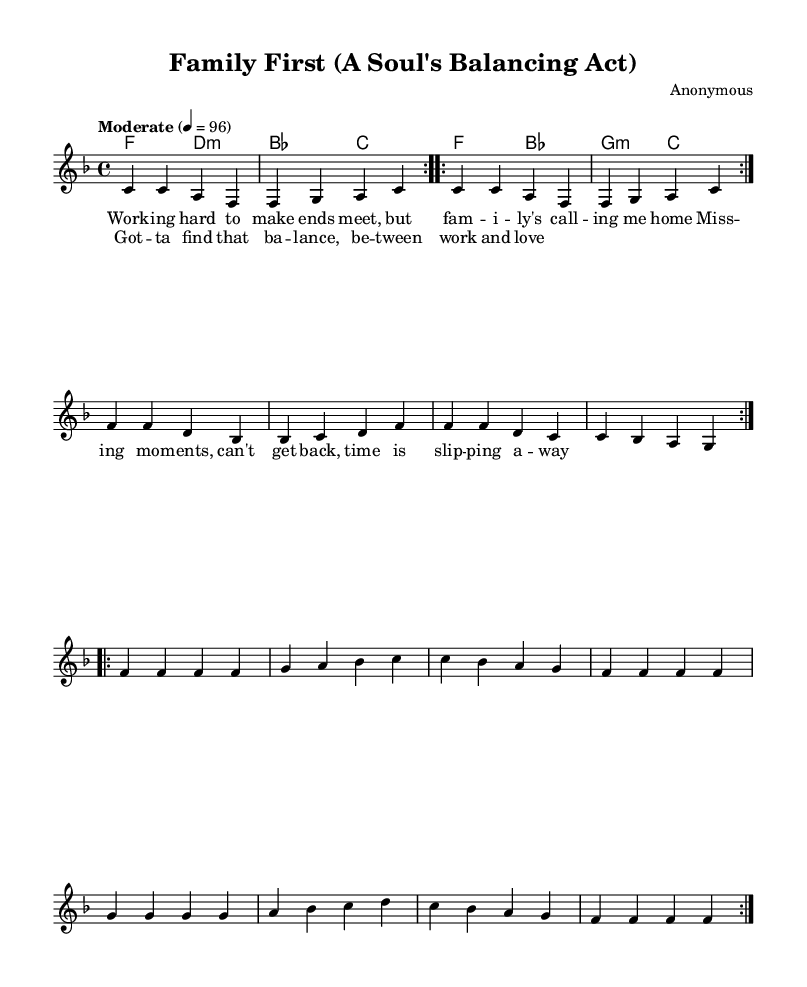What is the key signature of this music? The key signature is F major, which has one flat (B flat). This is determined by the `\key f \major` command found in the global setup indicating F major.
Answer: F major What is the time signature of the piece? The time signature is 4/4. This is indicated by the `\time 4/4` command in the global setup, meaning there are four beats per measure.
Answer: 4/4 What is the tempo marking for this music? The tempo marking is "Moderate." This is expressed in the `\tempo "Moderate" 4 = 96` instruction, suggesting a moderate pace of 96 beats per minute.
Answer: Moderate How many times is the chorus repeated? The chorus is repeated twice, as indicated by the `\repeat volta 2` notation before the chorus lyrics. This shows that the section should be played two times.
Answer: 2 What is the first chord of the melody? The first chord of the melody is F major. This is indicated at the start of the `\chordmode` section, where the first chord is listed as `f2`.
Answer: F major How does the melody for the chorus differ from the verse? The melody for the chorus is simpler, generally repeating phrases without the varied melodic line seen in the verse. This observation can be made by comparing the rhythmic and melodic structure of the two sections; the verse contains more varied notes, while the chorus tends to encapsulate a repeated theme.
Answer: Simpler, repetitive What family theme does this piece emphasize? This piece emphasizes prioritizing family. The lyrics focus on the struggle between work commitments and the desire to connect with loved ones, reflecting a common sentiment of the time about balancing professional and personal life.
Answer: Prioritizing family 